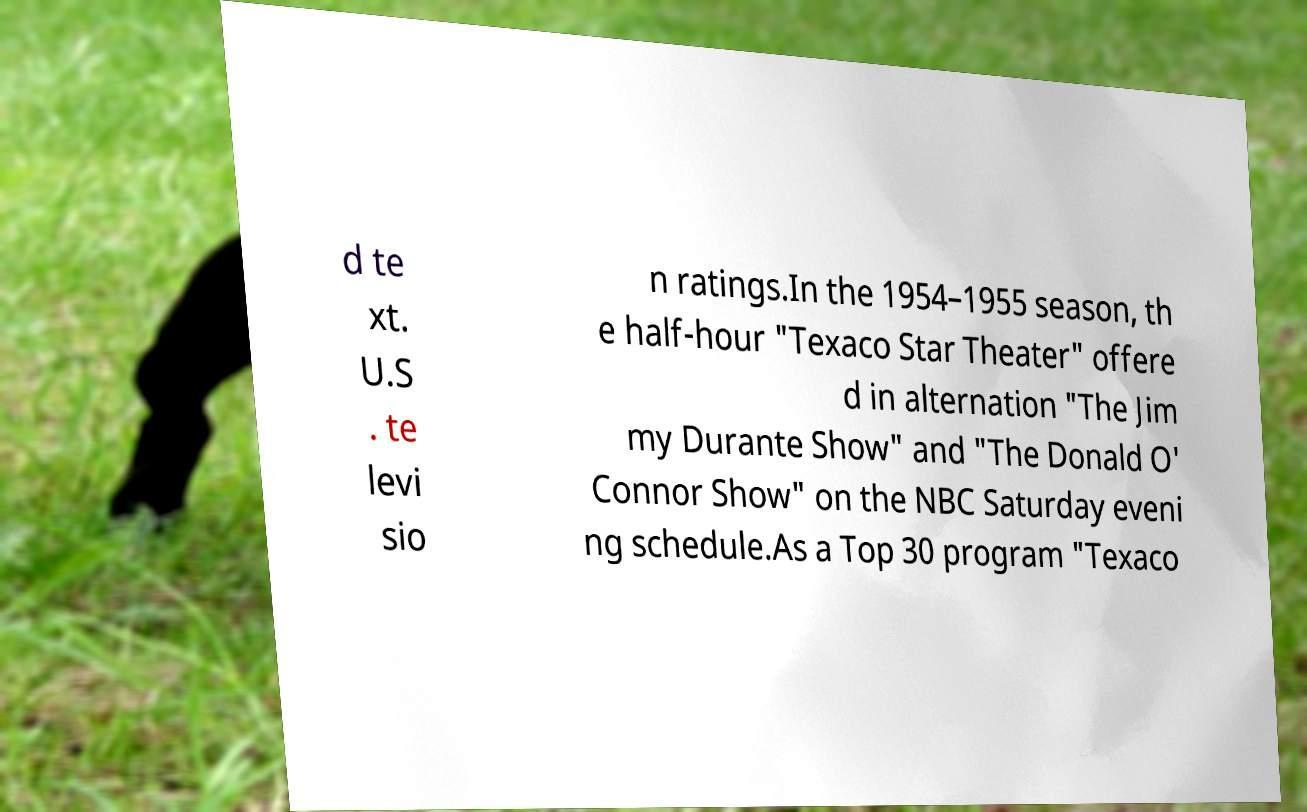Please identify and transcribe the text found in this image. d te xt. U.S . te levi sio n ratings.In the 1954–1955 season, th e half-hour "Texaco Star Theater" offere d in alternation "The Jim my Durante Show" and "The Donald O' Connor Show" on the NBC Saturday eveni ng schedule.As a Top 30 program "Texaco 